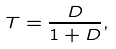Convert formula to latex. <formula><loc_0><loc_0><loc_500><loc_500>T = \frac { D } { 1 + D } ,</formula> 